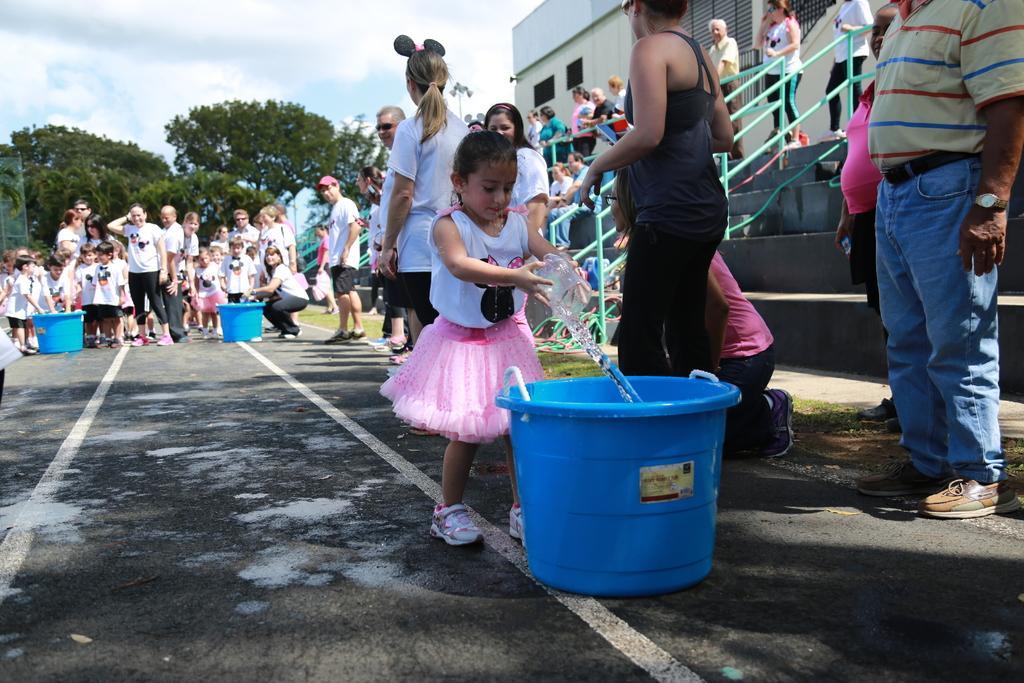Describe this image in one or two sentences. In this image we can see the kids and also the people. We can also see the road, blue color objects and also some other objects. We can see the building, railing, stairs and also the grass. In the background we can see the trees and also the sky with the clouds. 